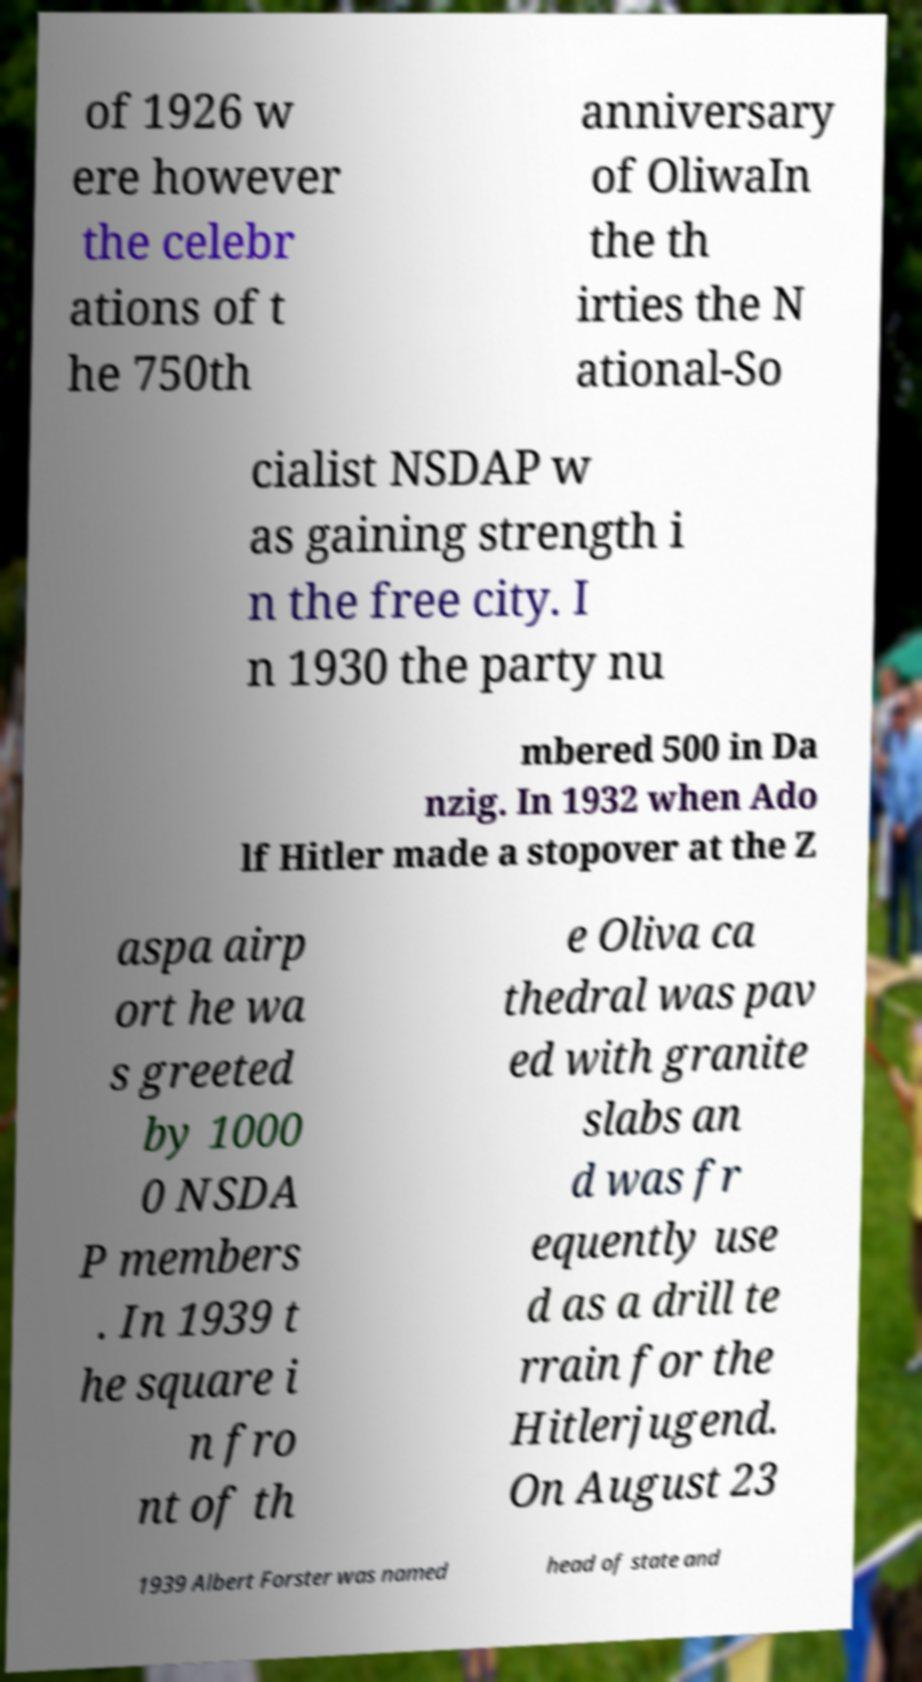Can you accurately transcribe the text from the provided image for me? of 1926 w ere however the celebr ations of t he 750th anniversary of OliwaIn the th irties the N ational-So cialist NSDAP w as gaining strength i n the free city. I n 1930 the party nu mbered 500 in Da nzig. In 1932 when Ado lf Hitler made a stopover at the Z aspa airp ort he wa s greeted by 1000 0 NSDA P members . In 1939 t he square i n fro nt of th e Oliva ca thedral was pav ed with granite slabs an d was fr equently use d as a drill te rrain for the Hitlerjugend. On August 23 1939 Albert Forster was named head of state and 